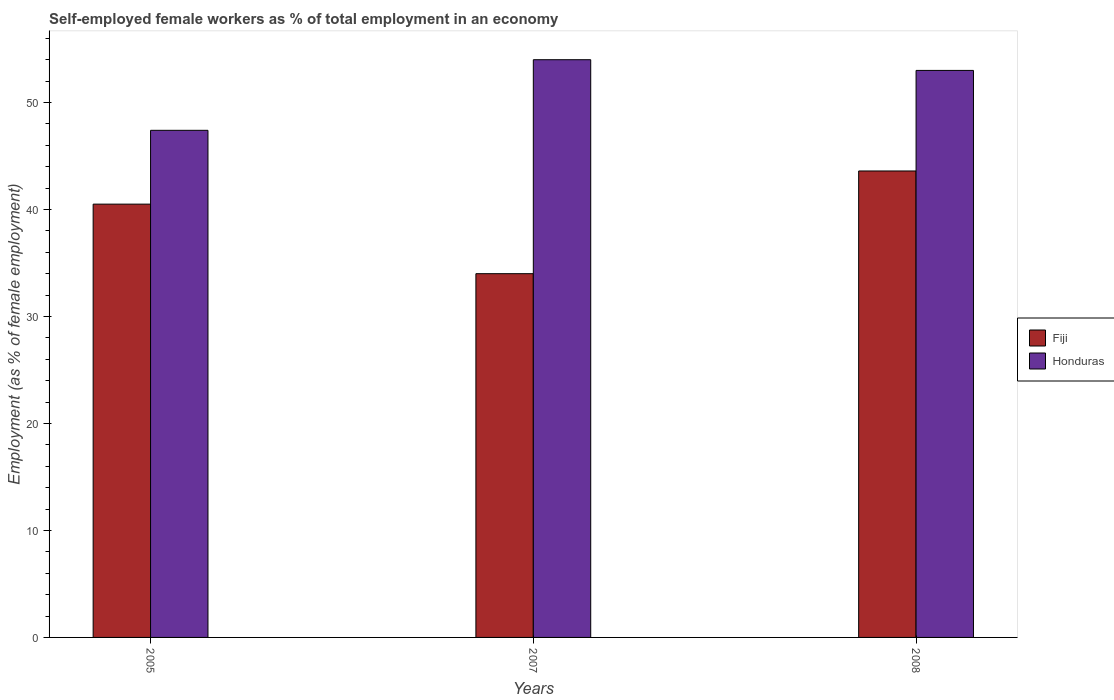How many different coloured bars are there?
Your answer should be compact. 2. How many groups of bars are there?
Your answer should be very brief. 3. Are the number of bars per tick equal to the number of legend labels?
Your answer should be very brief. Yes. How many bars are there on the 2nd tick from the left?
Your response must be concise. 2. What is the label of the 2nd group of bars from the left?
Your answer should be very brief. 2007. Across all years, what is the minimum percentage of self-employed female workers in Honduras?
Ensure brevity in your answer.  47.4. In which year was the percentage of self-employed female workers in Fiji maximum?
Make the answer very short. 2008. In which year was the percentage of self-employed female workers in Fiji minimum?
Keep it short and to the point. 2007. What is the total percentage of self-employed female workers in Honduras in the graph?
Offer a terse response. 154.4. What is the difference between the percentage of self-employed female workers in Honduras in 2005 and that in 2007?
Offer a terse response. -6.6. What is the difference between the percentage of self-employed female workers in Honduras in 2008 and the percentage of self-employed female workers in Fiji in 2005?
Your response must be concise. 12.5. What is the average percentage of self-employed female workers in Honduras per year?
Your response must be concise. 51.47. In the year 2008, what is the difference between the percentage of self-employed female workers in Fiji and percentage of self-employed female workers in Honduras?
Keep it short and to the point. -9.4. What is the ratio of the percentage of self-employed female workers in Honduras in 2005 to that in 2008?
Provide a succinct answer. 0.89. Is the difference between the percentage of self-employed female workers in Fiji in 2007 and 2008 greater than the difference between the percentage of self-employed female workers in Honduras in 2007 and 2008?
Ensure brevity in your answer.  No. What is the difference between the highest and the second highest percentage of self-employed female workers in Fiji?
Offer a very short reply. 3.1. What is the difference between the highest and the lowest percentage of self-employed female workers in Fiji?
Your response must be concise. 9.6. What does the 1st bar from the left in 2007 represents?
Your response must be concise. Fiji. What does the 2nd bar from the right in 2005 represents?
Give a very brief answer. Fiji. Are all the bars in the graph horizontal?
Give a very brief answer. No. How many years are there in the graph?
Your response must be concise. 3. What is the difference between two consecutive major ticks on the Y-axis?
Your answer should be very brief. 10. Are the values on the major ticks of Y-axis written in scientific E-notation?
Your answer should be very brief. No. How many legend labels are there?
Offer a terse response. 2. What is the title of the graph?
Offer a terse response. Self-employed female workers as % of total employment in an economy. What is the label or title of the X-axis?
Ensure brevity in your answer.  Years. What is the label or title of the Y-axis?
Provide a short and direct response. Employment (as % of female employment). What is the Employment (as % of female employment) of Fiji in 2005?
Ensure brevity in your answer.  40.5. What is the Employment (as % of female employment) of Honduras in 2005?
Your response must be concise. 47.4. What is the Employment (as % of female employment) of Fiji in 2007?
Ensure brevity in your answer.  34. What is the Employment (as % of female employment) of Honduras in 2007?
Give a very brief answer. 54. What is the Employment (as % of female employment) in Fiji in 2008?
Your answer should be very brief. 43.6. Across all years, what is the maximum Employment (as % of female employment) in Fiji?
Make the answer very short. 43.6. Across all years, what is the maximum Employment (as % of female employment) in Honduras?
Your answer should be very brief. 54. Across all years, what is the minimum Employment (as % of female employment) in Honduras?
Offer a terse response. 47.4. What is the total Employment (as % of female employment) of Fiji in the graph?
Your response must be concise. 118.1. What is the total Employment (as % of female employment) of Honduras in the graph?
Your answer should be compact. 154.4. What is the difference between the Employment (as % of female employment) in Fiji in 2007 and that in 2008?
Offer a terse response. -9.6. What is the difference between the Employment (as % of female employment) in Honduras in 2007 and that in 2008?
Offer a very short reply. 1. What is the difference between the Employment (as % of female employment) in Fiji in 2005 and the Employment (as % of female employment) in Honduras in 2008?
Provide a succinct answer. -12.5. What is the average Employment (as % of female employment) in Fiji per year?
Make the answer very short. 39.37. What is the average Employment (as % of female employment) of Honduras per year?
Ensure brevity in your answer.  51.47. In the year 2007, what is the difference between the Employment (as % of female employment) of Fiji and Employment (as % of female employment) of Honduras?
Your answer should be very brief. -20. In the year 2008, what is the difference between the Employment (as % of female employment) of Fiji and Employment (as % of female employment) of Honduras?
Keep it short and to the point. -9.4. What is the ratio of the Employment (as % of female employment) in Fiji in 2005 to that in 2007?
Provide a short and direct response. 1.19. What is the ratio of the Employment (as % of female employment) of Honduras in 2005 to that in 2007?
Provide a succinct answer. 0.88. What is the ratio of the Employment (as % of female employment) in Fiji in 2005 to that in 2008?
Offer a terse response. 0.93. What is the ratio of the Employment (as % of female employment) of Honduras in 2005 to that in 2008?
Your answer should be compact. 0.89. What is the ratio of the Employment (as % of female employment) in Fiji in 2007 to that in 2008?
Your answer should be compact. 0.78. What is the ratio of the Employment (as % of female employment) in Honduras in 2007 to that in 2008?
Your answer should be very brief. 1.02. What is the difference between the highest and the second highest Employment (as % of female employment) in Honduras?
Give a very brief answer. 1. What is the difference between the highest and the lowest Employment (as % of female employment) of Fiji?
Keep it short and to the point. 9.6. 